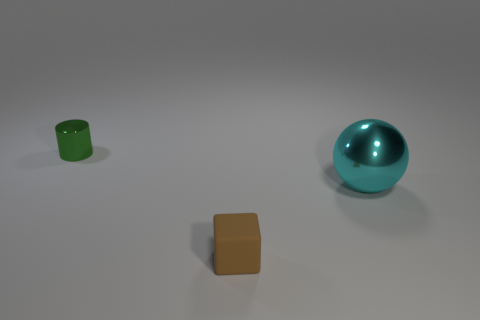Is there any other thing that is made of the same material as the small cube?
Offer a very short reply. No. There is a small cylinder that is the same material as the large cyan ball; what is its color?
Make the answer very short. Green. Are there more matte cubes than big yellow metal spheres?
Ensure brevity in your answer.  Yes. Are the large cyan ball and the cube made of the same material?
Provide a succinct answer. No. What is the shape of the object that is the same material as the green cylinder?
Your answer should be very brief. Sphere. Are there fewer large metal things than purple balls?
Your answer should be compact. No. There is a object that is in front of the tiny metal object and to the left of the big metal object; what material is it made of?
Offer a very short reply. Rubber. There is a object that is left of the object that is in front of the metallic thing to the right of the green shiny object; how big is it?
Provide a succinct answer. Small. What number of things are both to the left of the large cyan metallic object and to the right of the tiny green metal thing?
Offer a terse response. 1. How many yellow things are tiny matte blocks or shiny balls?
Provide a short and direct response. 0. 